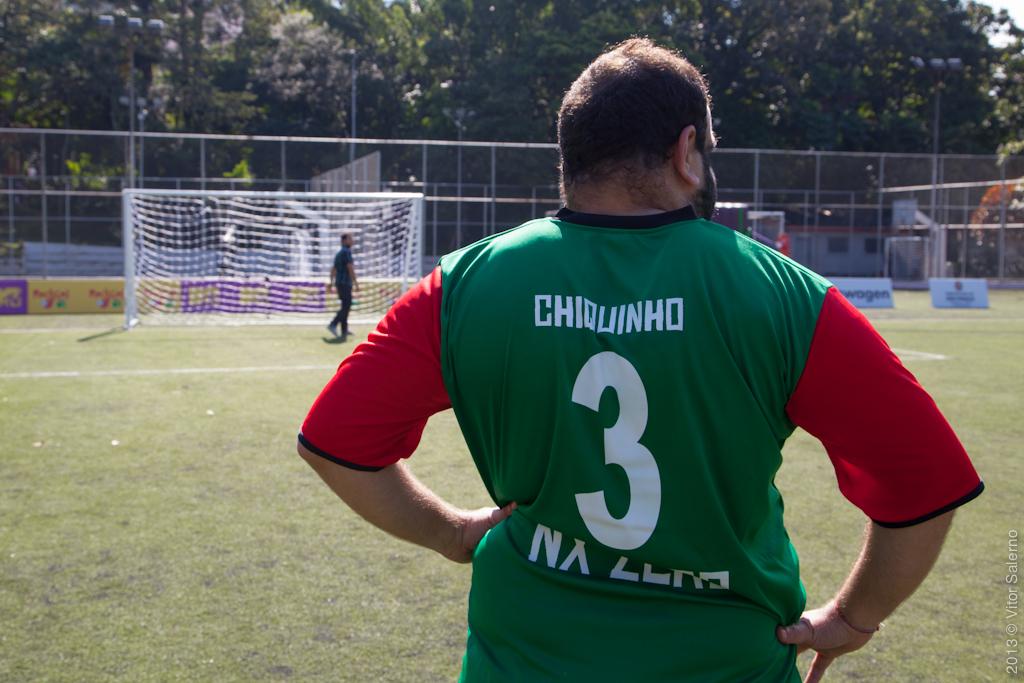What is the player's name on the jersey?
Give a very brief answer. Chiquinho. What number does this player wear?
Your answer should be very brief. 3. 